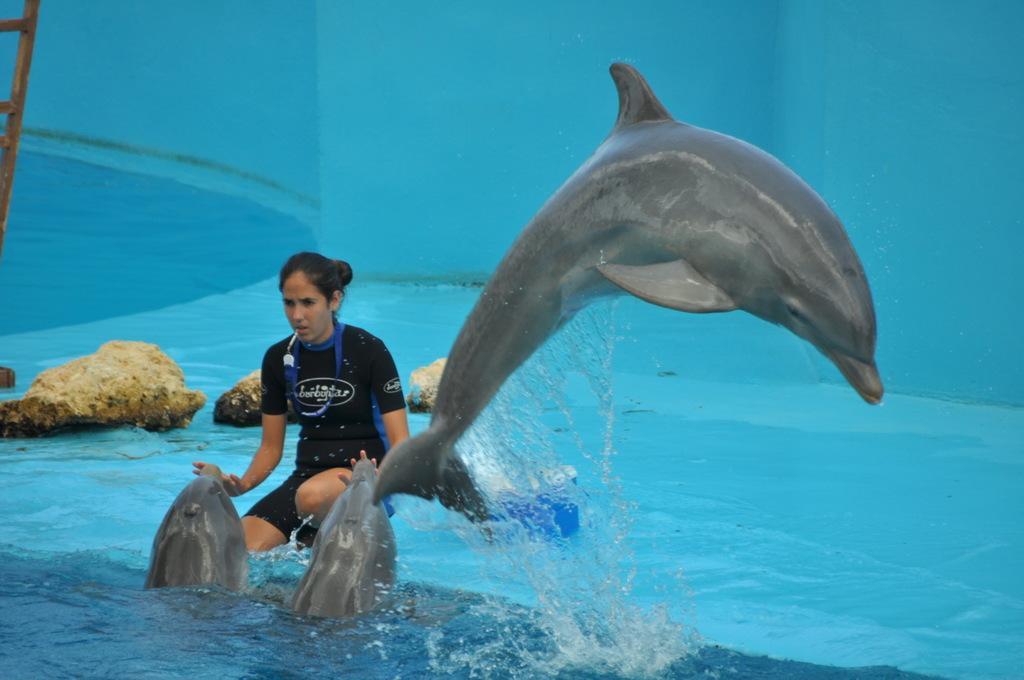Describe this image in one or two sentences. In this picture we can see a woman playing with the dolphins. Behind the women there are rocks and a blue background. 